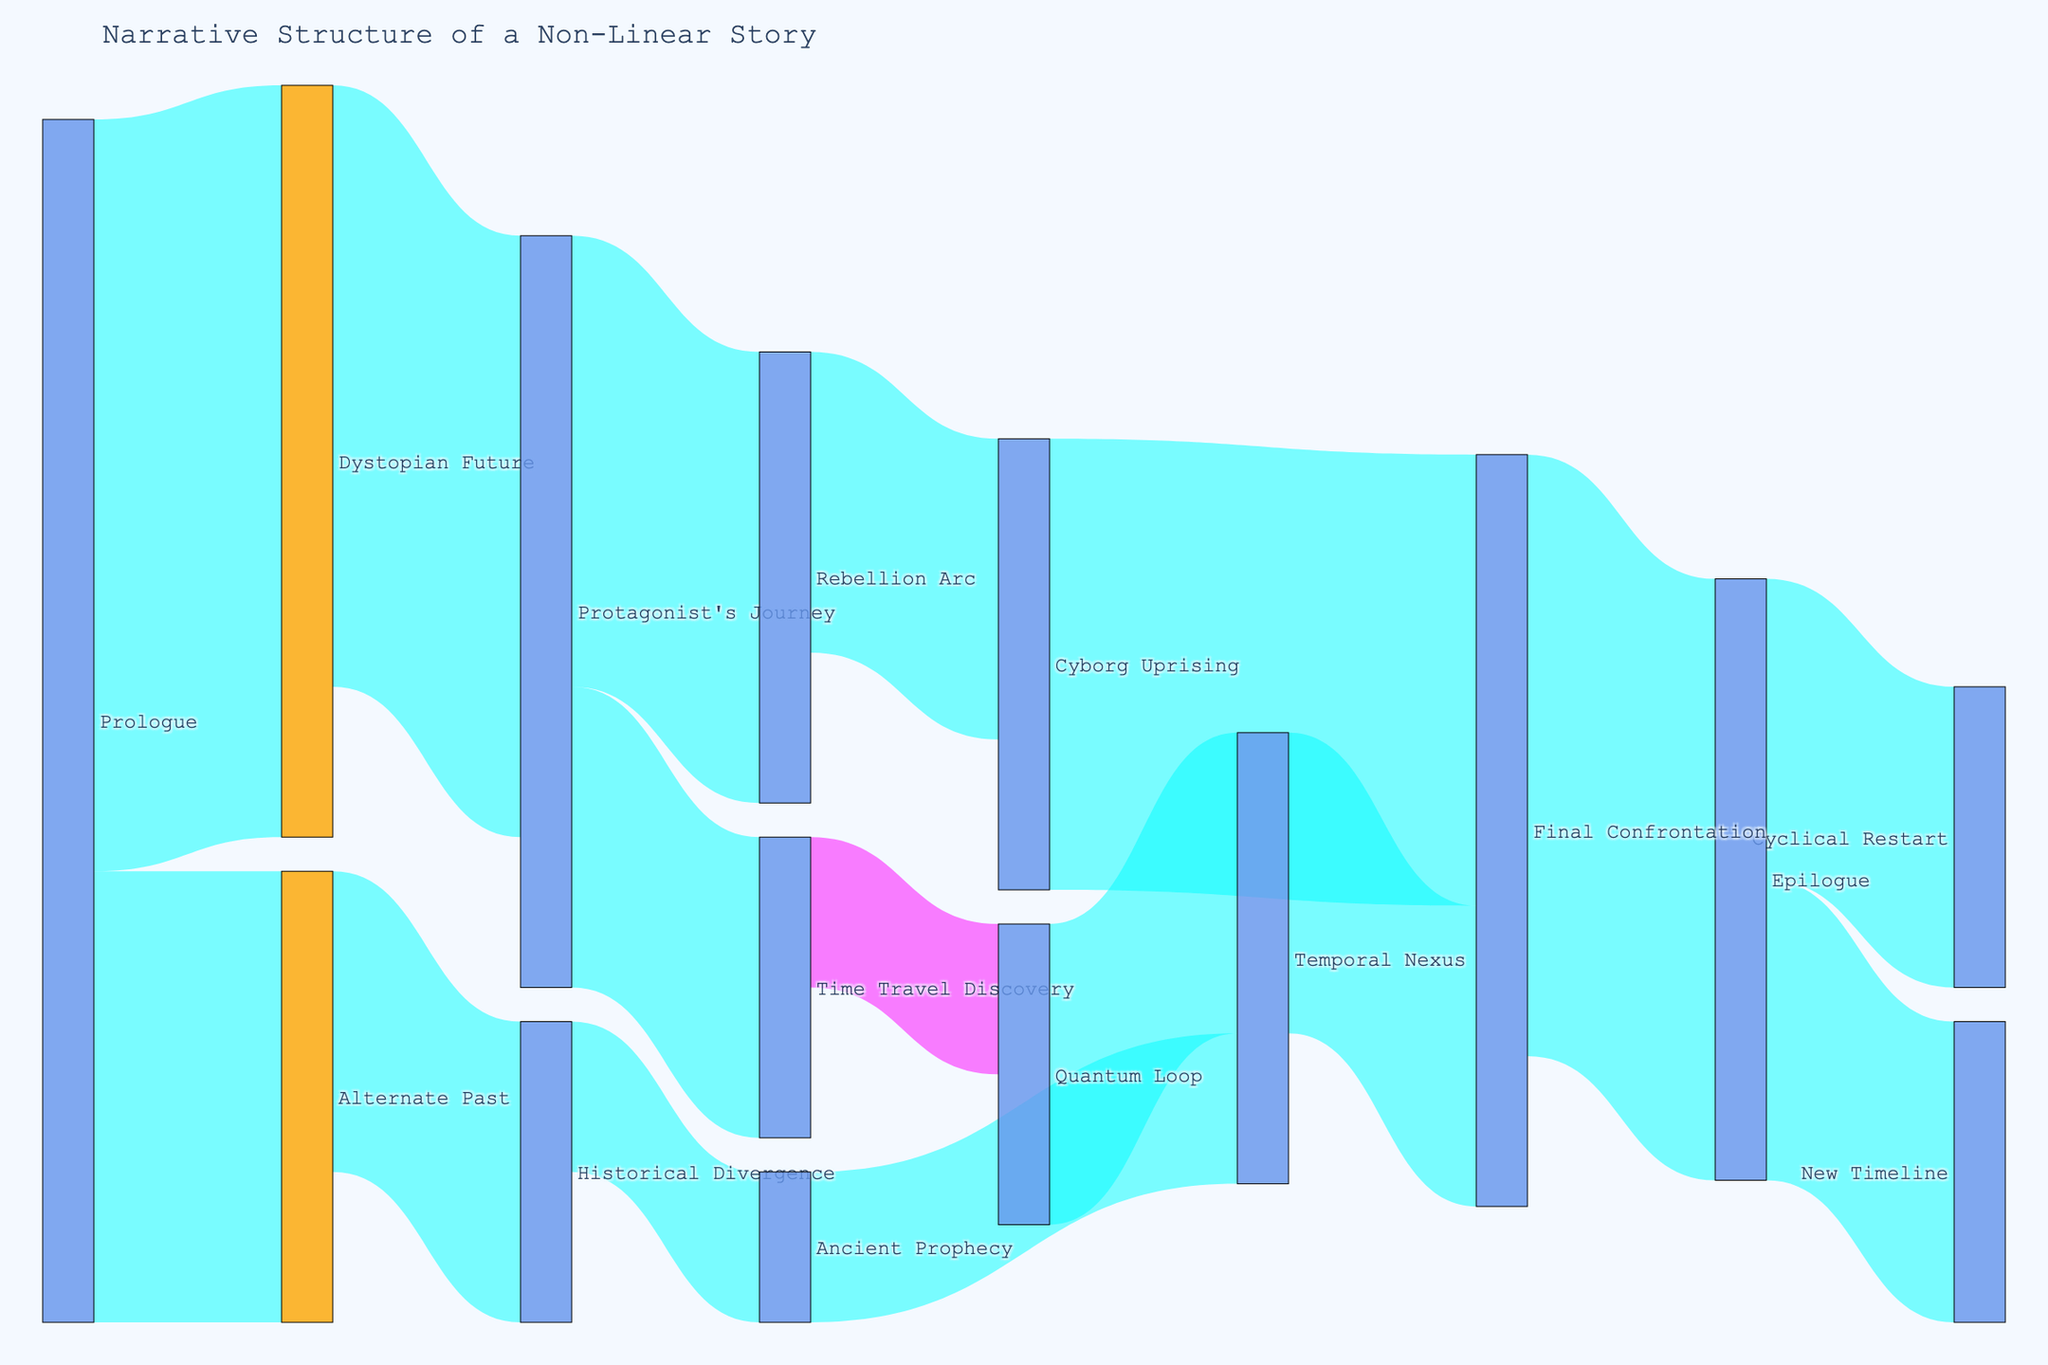What is the title of the diagram? The title of the diagram is displayed at the top of the figure, which reads "Narrative Structure of a Non-Linear Story".
Answer: Narrative Structure of a Non-Linear Story Which two arcs does the Prologue lead to, and what are their respective values? Referring to the Sankey diagram, the Prologue leads to two arcs: "Dystopian Future" with a value of 5, and "Alternate Past" with a value of 3.
Answer: Dystopian Future: 5, Alternate Past: 3 How many arcs lead into the Final Confrontation, and what are those arcs? The Final Confrontation is connected to three arcs in the diagram: "Cyborg Uprising" with a value of 3, "Temporal Nexus" with a value of 2, and "Epilogue" with a value of 4.
Answer: Three arcs: Cyborg Uprising, Temporal Nexus, Epilogue What is the sum of all values leading to the Protagonist's Journey? The Protagonist's Journey has one direct lead from "Dystopian Future," which carries a value of 4. Summing these gives us 4.
Answer: 4 Which arc has the highest value for connections originating from it, and what is that value? The Prologue has the highest outgoing value, with the values 5 and 3, totaling 8, originating from it.
Answer: Prologue: 8 Compare the values associated with "Time Travel Discovery" and "Historical Divergence." Which one has a higher total value? The "Time Travel Discovery" leads to one arc with a value of 2; "Historical Divergence" leads to the "Ancient Prophecy" with a value of 1. Comparing these, "Time Travel Discovery" has a higher total value of 2.
Answer: Time Travel Discovery What is the value of arcs originating from "Protagonist's Journey", and how do these values compare to each other? "Protagonist's Journey" has outgoing arcs leading to "Rebellion Arc" (value 3) and "Time Travel Discovery" (value 2). The value for "Rebellion Arc" is greater than "Time Travel Discovery".
Answer: Rebellion Arc: 3, Time Travel Discovery: 2 Identify a node where all incoming and outgoing arcs' combined values are equal. The node "Protagonist's Journey" has an incoming value of 4 (from Dystopian Future) and an outgoing total value of 3 (Rebellion Arc) + 2 (Time Travel Discovery), summing to 5. However, an equal sum example is "Epilogue," with incoming arcs from "Final Confrontation" (value 4), and outgoing total value of 2 (New Timeline) + 2 (Cyclical Restart), totaling 4.
Answer: Epilogue 